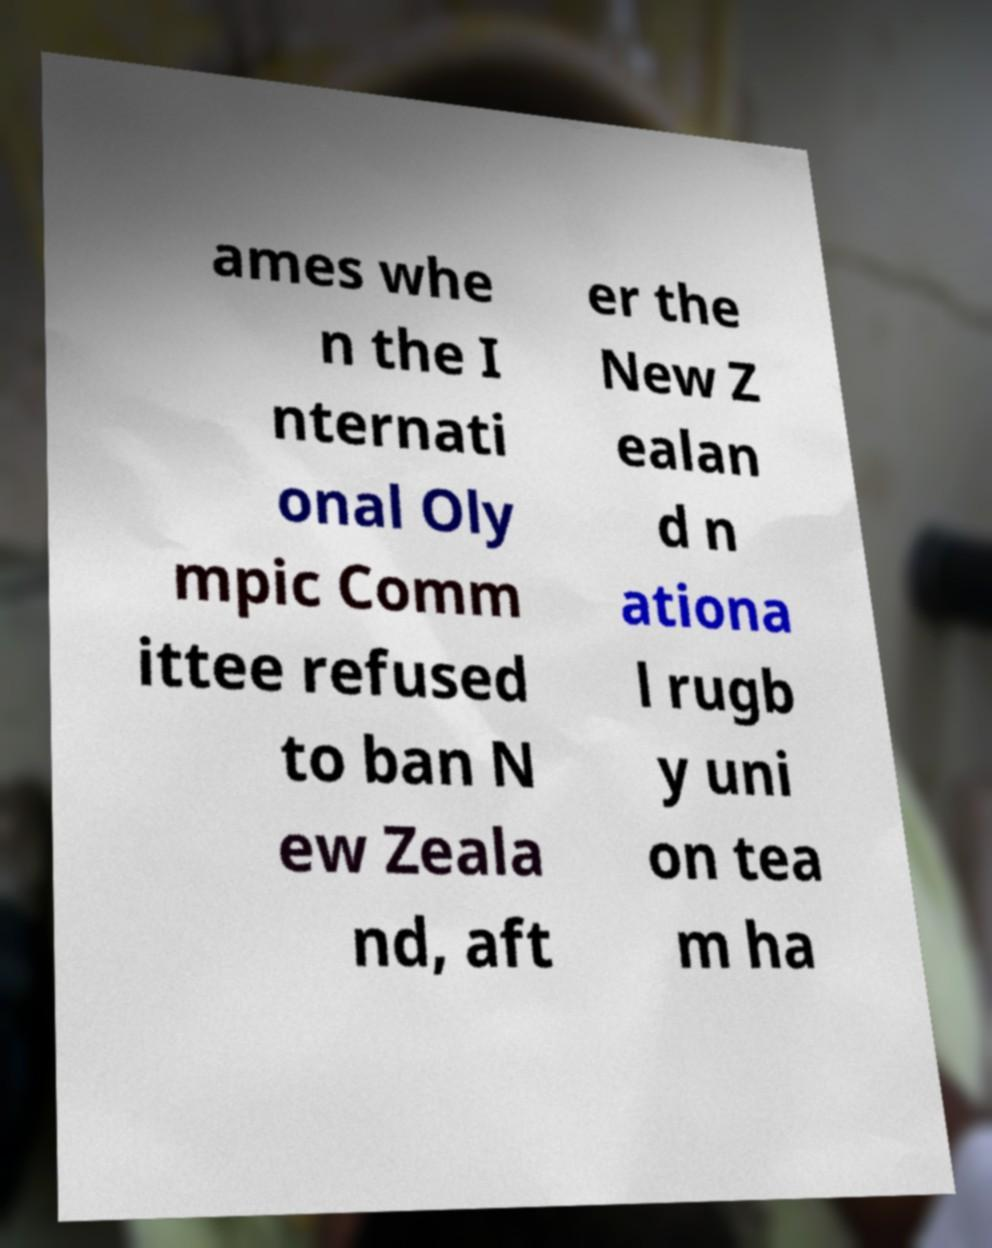There's text embedded in this image that I need extracted. Can you transcribe it verbatim? ames whe n the I nternati onal Oly mpic Comm ittee refused to ban N ew Zeala nd, aft er the New Z ealan d n ationa l rugb y uni on tea m ha 